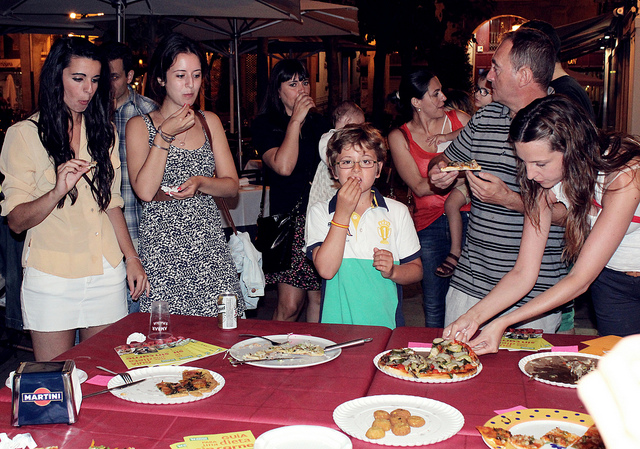Read all the text in this image. MARTINI 